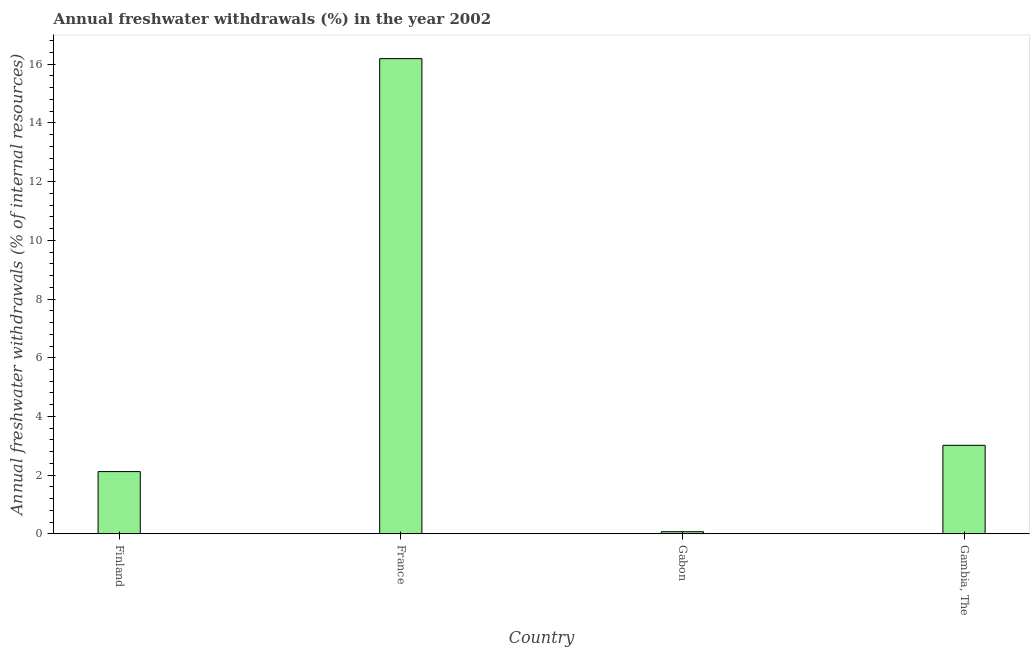What is the title of the graph?
Offer a terse response. Annual freshwater withdrawals (%) in the year 2002. What is the label or title of the X-axis?
Make the answer very short. Country. What is the label or title of the Y-axis?
Provide a succinct answer. Annual freshwater withdrawals (% of internal resources). What is the annual freshwater withdrawals in Gambia, The?
Offer a very short reply. 3.02. Across all countries, what is the maximum annual freshwater withdrawals?
Ensure brevity in your answer.  16.19. Across all countries, what is the minimum annual freshwater withdrawals?
Give a very brief answer. 0.07. In which country was the annual freshwater withdrawals maximum?
Provide a succinct answer. France. In which country was the annual freshwater withdrawals minimum?
Provide a short and direct response. Gabon. What is the sum of the annual freshwater withdrawals?
Your answer should be very brief. 21.4. What is the difference between the annual freshwater withdrawals in Finland and Gabon?
Ensure brevity in your answer.  2.05. What is the average annual freshwater withdrawals per country?
Keep it short and to the point. 5.35. What is the median annual freshwater withdrawals?
Provide a succinct answer. 2.57. In how many countries, is the annual freshwater withdrawals greater than 15.6 %?
Make the answer very short. 1. What is the ratio of the annual freshwater withdrawals in Finland to that in Gambia, The?
Offer a terse response. 0.7. Is the annual freshwater withdrawals in Finland less than that in Gabon?
Ensure brevity in your answer.  No. What is the difference between the highest and the second highest annual freshwater withdrawals?
Your answer should be compact. 13.17. What is the difference between the highest and the lowest annual freshwater withdrawals?
Your response must be concise. 16.12. Are the values on the major ticks of Y-axis written in scientific E-notation?
Ensure brevity in your answer.  No. What is the Annual freshwater withdrawals (% of internal resources) of Finland?
Give a very brief answer. 2.12. What is the Annual freshwater withdrawals (% of internal resources) of France?
Ensure brevity in your answer.  16.19. What is the Annual freshwater withdrawals (% of internal resources) of Gabon?
Offer a very short reply. 0.07. What is the Annual freshwater withdrawals (% of internal resources) of Gambia, The?
Offer a very short reply. 3.02. What is the difference between the Annual freshwater withdrawals (% of internal resources) in Finland and France?
Offer a terse response. -14.07. What is the difference between the Annual freshwater withdrawals (% of internal resources) in Finland and Gabon?
Offer a terse response. 2.05. What is the difference between the Annual freshwater withdrawals (% of internal resources) in Finland and Gambia, The?
Make the answer very short. -0.9. What is the difference between the Annual freshwater withdrawals (% of internal resources) in France and Gabon?
Your answer should be very brief. 16.12. What is the difference between the Annual freshwater withdrawals (% of internal resources) in France and Gambia, The?
Provide a short and direct response. 13.17. What is the difference between the Annual freshwater withdrawals (% of internal resources) in Gabon and Gambia, The?
Your answer should be very brief. -2.94. What is the ratio of the Annual freshwater withdrawals (% of internal resources) in Finland to that in France?
Ensure brevity in your answer.  0.13. What is the ratio of the Annual freshwater withdrawals (% of internal resources) in Finland to that in Gabon?
Your answer should be very brief. 28.92. What is the ratio of the Annual freshwater withdrawals (% of internal resources) in Finland to that in Gambia, The?
Provide a short and direct response. 0.7. What is the ratio of the Annual freshwater withdrawals (% of internal resources) in France to that in Gabon?
Offer a very short reply. 220.71. What is the ratio of the Annual freshwater withdrawals (% of internal resources) in France to that in Gambia, The?
Ensure brevity in your answer.  5.37. What is the ratio of the Annual freshwater withdrawals (% of internal resources) in Gabon to that in Gambia, The?
Keep it short and to the point. 0.02. 